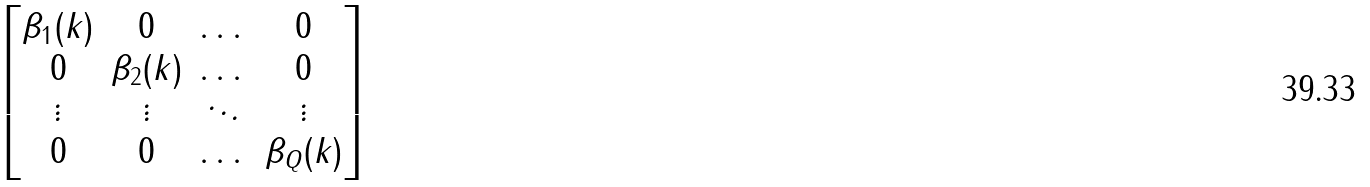Convert formula to latex. <formula><loc_0><loc_0><loc_500><loc_500>\begin{bmatrix} \beta _ { 1 } ( k ) & 0 & \dots & 0 \\ 0 & \beta _ { 2 } ( k ) & \dots & 0 \\ \vdots & \vdots & \ddots & \vdots \\ 0 & 0 & \dots & \beta _ { Q } ( k ) \end{bmatrix}</formula> 